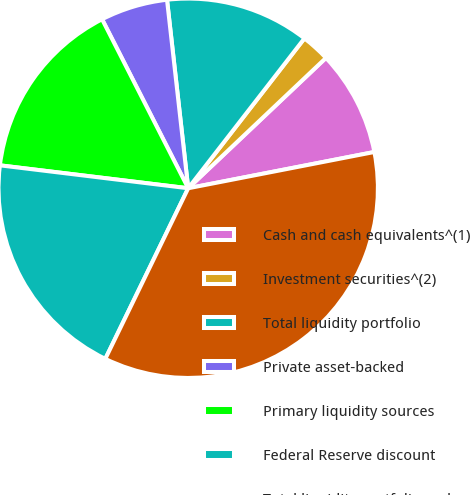Convert chart. <chart><loc_0><loc_0><loc_500><loc_500><pie_chart><fcel>Cash and cash equivalents^(1)<fcel>Investment securities^(2)<fcel>Total liquidity portfolio<fcel>Private asset-backed<fcel>Primary liquidity sources<fcel>Federal Reserve discount<fcel>Total liquidity portfolio and<nl><fcel>9.0%<fcel>2.44%<fcel>12.28%<fcel>5.72%<fcel>15.57%<fcel>19.73%<fcel>35.26%<nl></chart> 